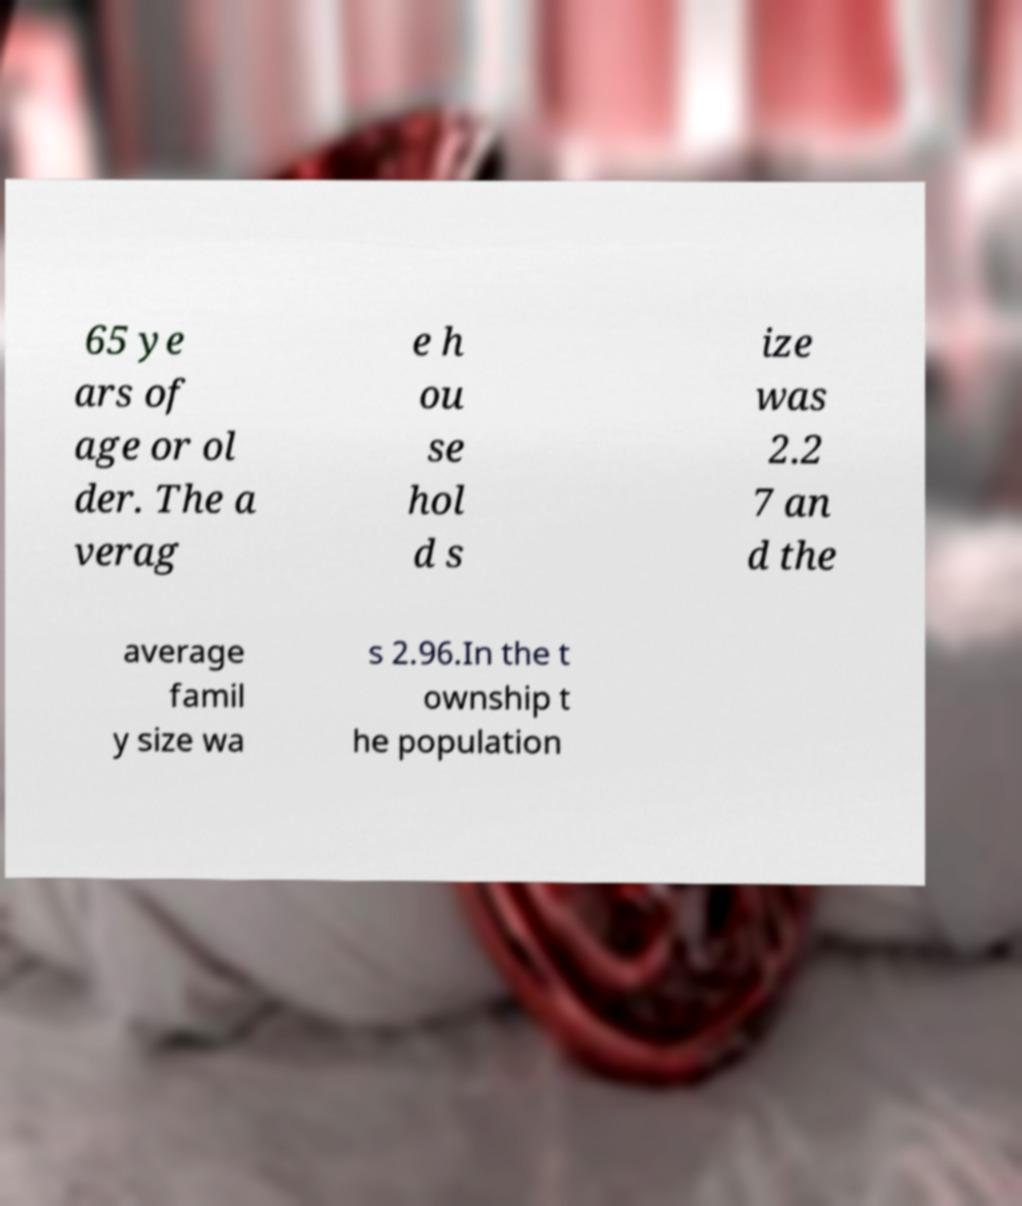Can you accurately transcribe the text from the provided image for me? 65 ye ars of age or ol der. The a verag e h ou se hol d s ize was 2.2 7 an d the average famil y size wa s 2.96.In the t ownship t he population 